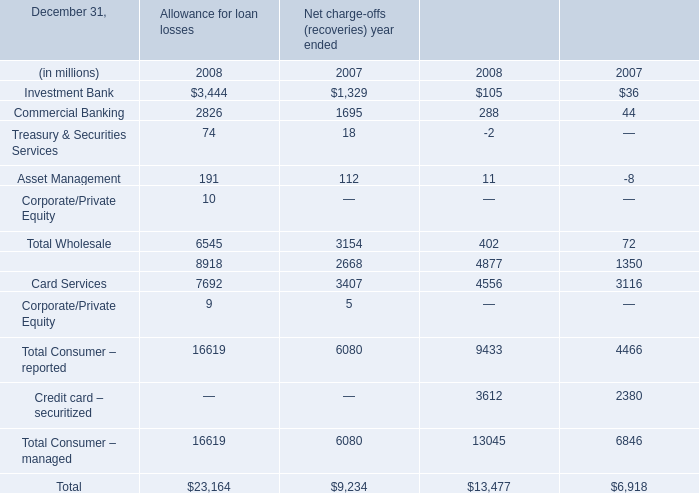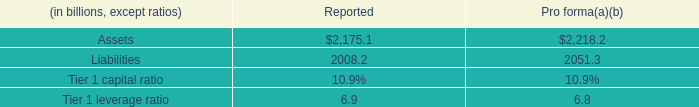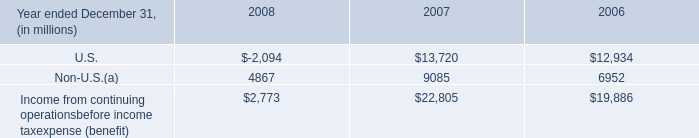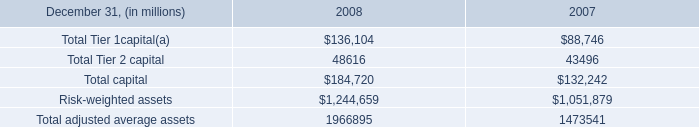how many years are under exam for the firm or it's recent acquired subsidiaries? 
Computations: (2005 - 2000)
Answer: 5.0. 